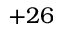Convert formula to latex. <formula><loc_0><loc_0><loc_500><loc_500>+ 2 6</formula> 